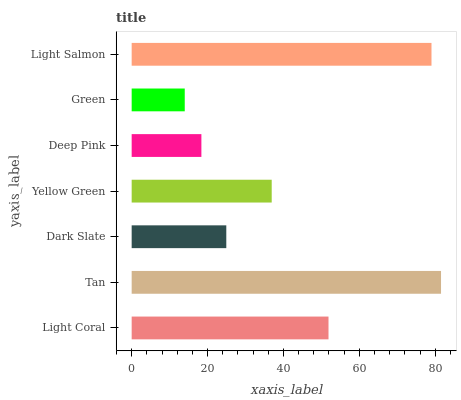Is Green the minimum?
Answer yes or no. Yes. Is Tan the maximum?
Answer yes or no. Yes. Is Dark Slate the minimum?
Answer yes or no. No. Is Dark Slate the maximum?
Answer yes or no. No. Is Tan greater than Dark Slate?
Answer yes or no. Yes. Is Dark Slate less than Tan?
Answer yes or no. Yes. Is Dark Slate greater than Tan?
Answer yes or no. No. Is Tan less than Dark Slate?
Answer yes or no. No. Is Yellow Green the high median?
Answer yes or no. Yes. Is Yellow Green the low median?
Answer yes or no. Yes. Is Light Salmon the high median?
Answer yes or no. No. Is Deep Pink the low median?
Answer yes or no. No. 